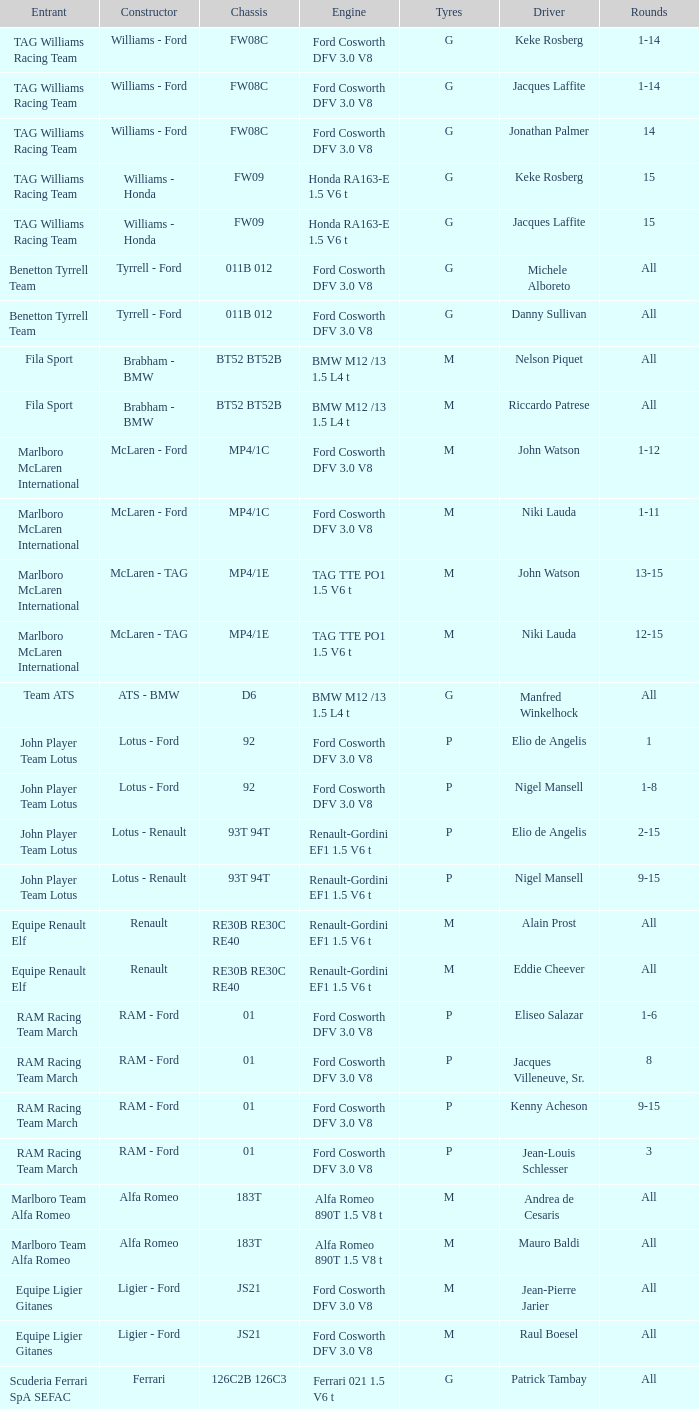0 v8 engine? Osella - Ford. 